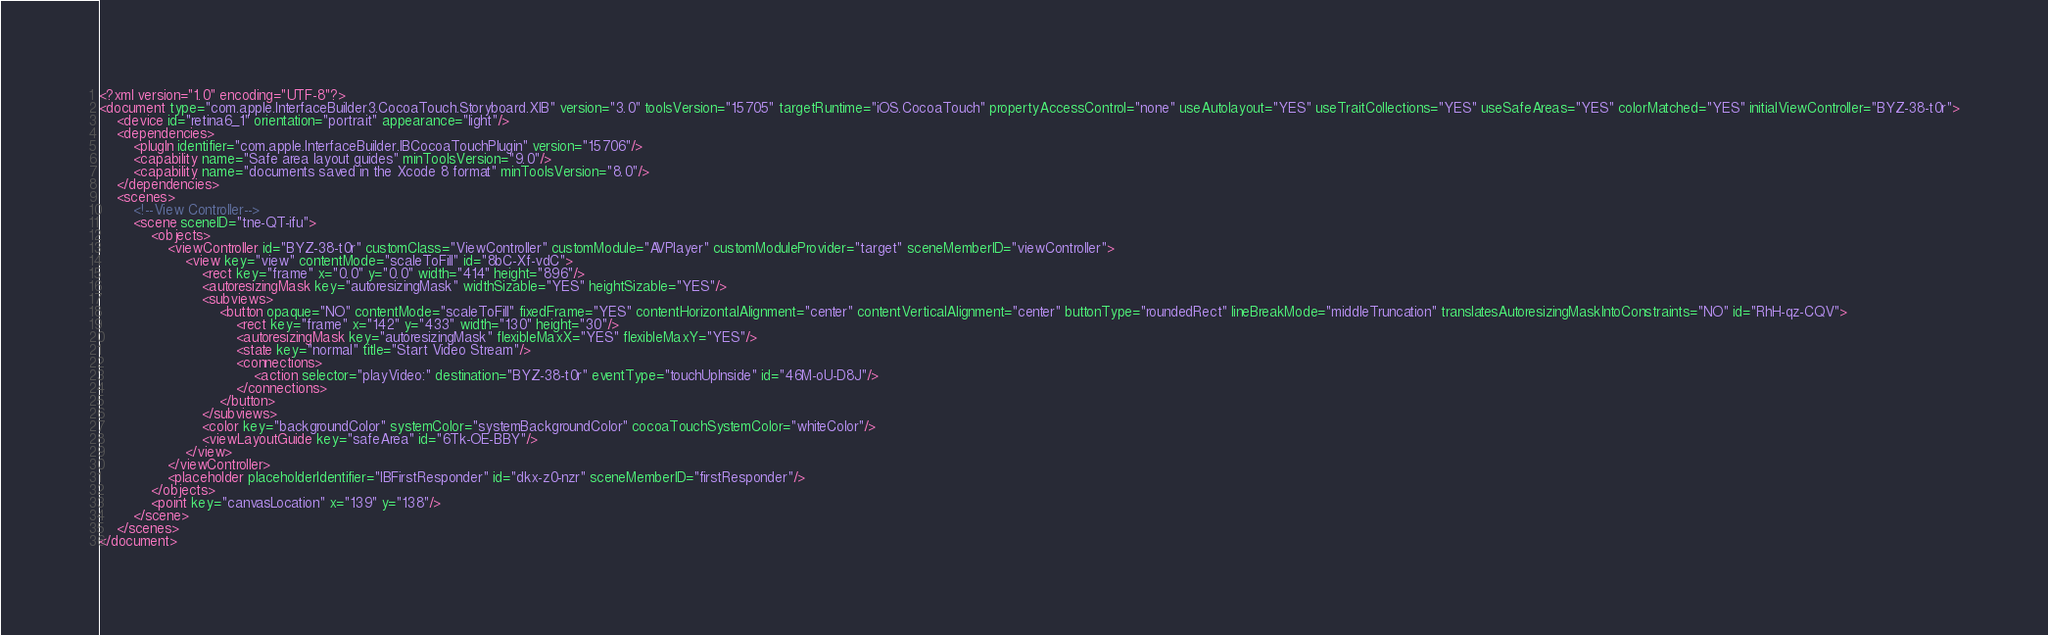Convert code to text. <code><loc_0><loc_0><loc_500><loc_500><_XML_><?xml version="1.0" encoding="UTF-8"?>
<document type="com.apple.InterfaceBuilder3.CocoaTouch.Storyboard.XIB" version="3.0" toolsVersion="15705" targetRuntime="iOS.CocoaTouch" propertyAccessControl="none" useAutolayout="YES" useTraitCollections="YES" useSafeAreas="YES" colorMatched="YES" initialViewController="BYZ-38-t0r">
    <device id="retina6_1" orientation="portrait" appearance="light"/>
    <dependencies>
        <plugIn identifier="com.apple.InterfaceBuilder.IBCocoaTouchPlugin" version="15706"/>
        <capability name="Safe area layout guides" minToolsVersion="9.0"/>
        <capability name="documents saved in the Xcode 8 format" minToolsVersion="8.0"/>
    </dependencies>
    <scenes>
        <!--View Controller-->
        <scene sceneID="tne-QT-ifu">
            <objects>
                <viewController id="BYZ-38-t0r" customClass="ViewController" customModule="AVPlayer" customModuleProvider="target" sceneMemberID="viewController">
                    <view key="view" contentMode="scaleToFill" id="8bC-Xf-vdC">
                        <rect key="frame" x="0.0" y="0.0" width="414" height="896"/>
                        <autoresizingMask key="autoresizingMask" widthSizable="YES" heightSizable="YES"/>
                        <subviews>
                            <button opaque="NO" contentMode="scaleToFill" fixedFrame="YES" contentHorizontalAlignment="center" contentVerticalAlignment="center" buttonType="roundedRect" lineBreakMode="middleTruncation" translatesAutoresizingMaskIntoConstraints="NO" id="RhH-qz-CQV">
                                <rect key="frame" x="142" y="433" width="130" height="30"/>
                                <autoresizingMask key="autoresizingMask" flexibleMaxX="YES" flexibleMaxY="YES"/>
                                <state key="normal" title="Start Video Stream"/>
                                <connections>
                                    <action selector="playVideo:" destination="BYZ-38-t0r" eventType="touchUpInside" id="46M-oU-D8J"/>
                                </connections>
                            </button>
                        </subviews>
                        <color key="backgroundColor" systemColor="systemBackgroundColor" cocoaTouchSystemColor="whiteColor"/>
                        <viewLayoutGuide key="safeArea" id="6Tk-OE-BBY"/>
                    </view>
                </viewController>
                <placeholder placeholderIdentifier="IBFirstResponder" id="dkx-z0-nzr" sceneMemberID="firstResponder"/>
            </objects>
            <point key="canvasLocation" x="139" y="138"/>
        </scene>
    </scenes>
</document>
</code> 